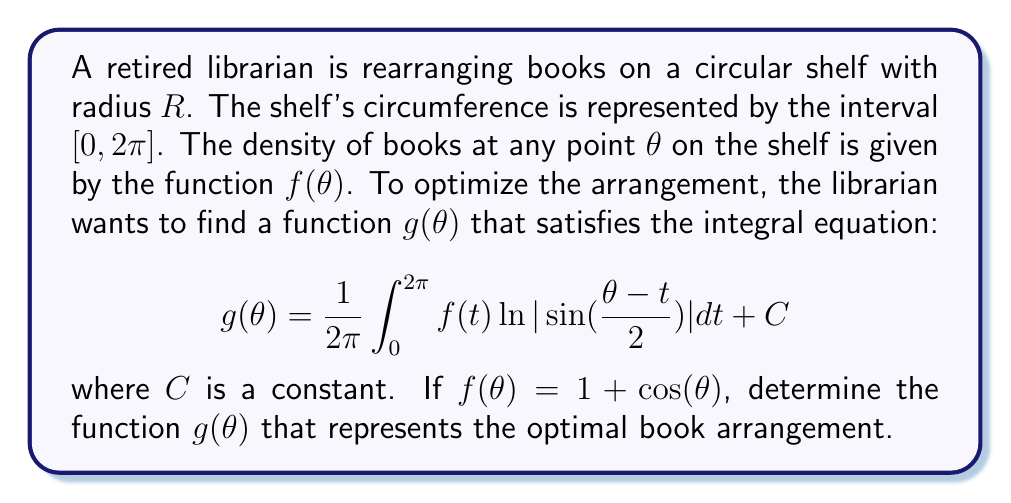Teach me how to tackle this problem. To solve this integral equation, we'll follow these steps:

1) First, we recognize this as a Fredholm integral equation of the first kind. The kernel of the equation is $K(\theta,t) = \frac{1}{2\pi} \ln|\sin(\frac{\theta-t}{2})|$.

2) We can use the Fourier series method to solve this equation. The Fourier series of $\ln|\sin(\frac{\theta}{2})|$ is known:

   $$\ln|\sin(\frac{\theta}{2})| = -\ln 2 - \sum_{n=1}^{\infty} \frac{\cos(n\theta)}{n}$$

3) Substituting this into our equation:

   $$g(\theta) = -\frac{1}{2\pi} \int_0^{2\pi} f(t) \ln 2 dt - \frac{1}{2\pi} \int_0^{2\pi} f(t) \sum_{n=1}^{\infty} \frac{\cos(n(\theta-t))}{n} dt + C$$

4) Given $f(\theta) = 1 + \cos(\theta)$, we can expand this:

   $$g(\theta) = -\ln 2 - \frac{1}{2\pi} \int_0^{2\pi} (1 + \cos(t)) \sum_{n=1}^{\infty} \frac{\cos(n\theta)\cos(nt) + \sin(n\theta)\sin(nt)}{n} dt + C$$

5) Using orthogonality of trigonometric functions, we can simplify this to:

   $$g(\theta) = -\ln 2 - \sum_{n=1}^{\infty} \frac{\cos(n\theta)}{n} - \frac{1}{2} \cos(\theta) + C$$

6) We recognize the sum as part of the Fourier series of $\ln|\sin(\frac{\theta}{2})|$, so we can write:

   $$g(\theta) = \ln|\sin(\frac{\theta}{2})| - \frac{1}{2} \cos(\theta) + C'$$

where $C'$ is a new constant that absorbs $C$ and any constants from the simplification.
Answer: $g(\theta) = \ln|\sin(\frac{\theta}{2})| - \frac{1}{2} \cos(\theta) + C$ 